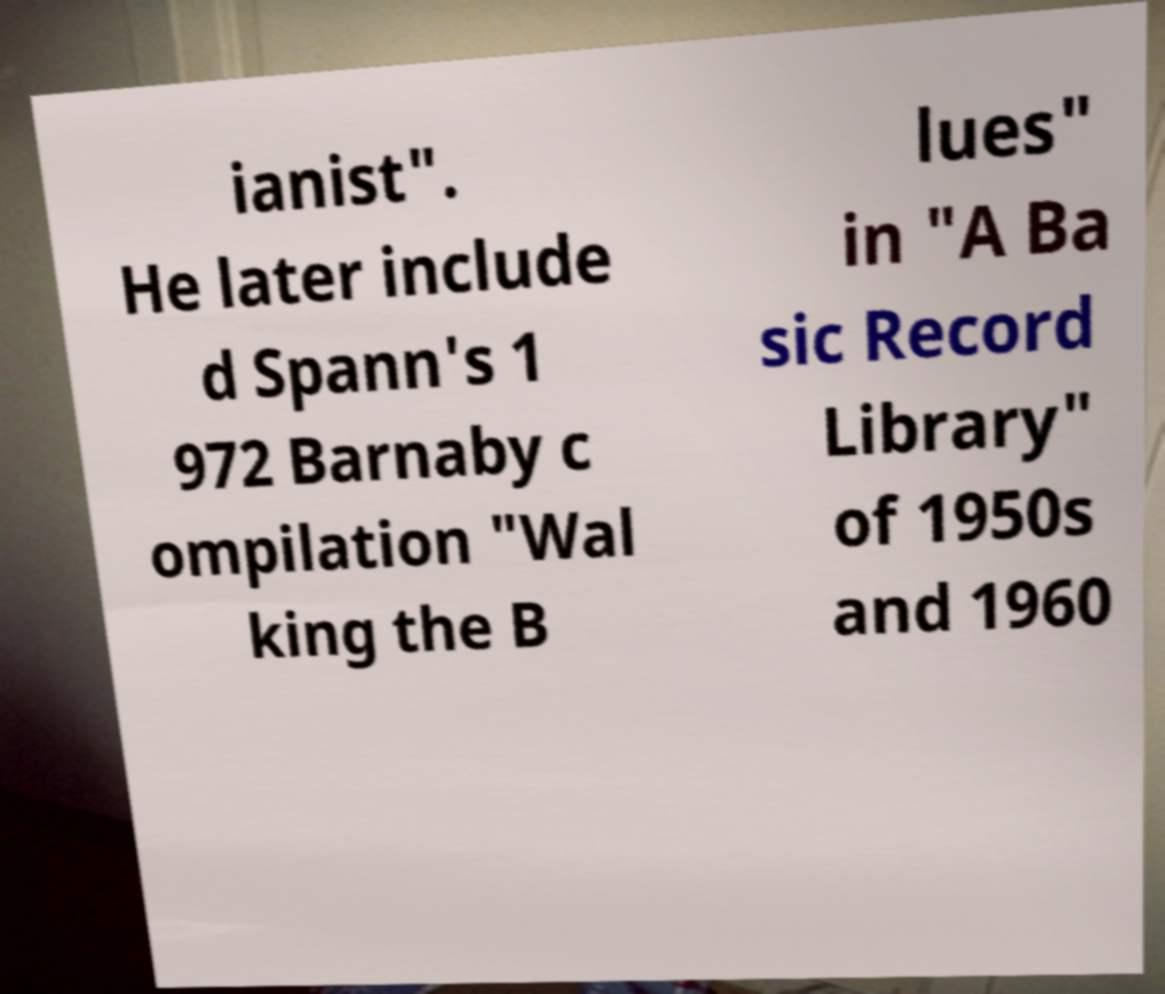Can you accurately transcribe the text from the provided image for me? ianist". He later include d Spann's 1 972 Barnaby c ompilation "Wal king the B lues" in "A Ba sic Record Library" of 1950s and 1960 